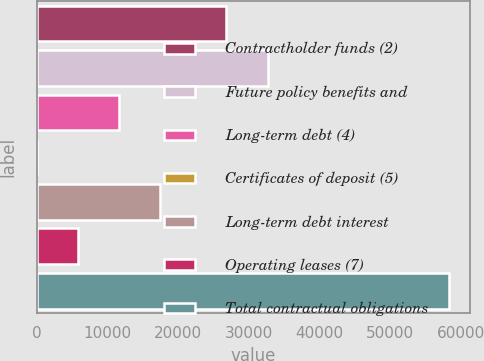Convert chart to OTSL. <chart><loc_0><loc_0><loc_500><loc_500><bar_chart><fcel>Contractholder funds (2)<fcel>Future policy benefits and<fcel>Long-term debt (4)<fcel>Certificates of deposit (5)<fcel>Long-term debt interest<fcel>Operating leases (7)<fcel>Total contractual obligations<nl><fcel>26859.8<fcel>32698.8<fcel>11678.2<fcel>0.1<fcel>17517.2<fcel>5839.13<fcel>58390.4<nl></chart> 